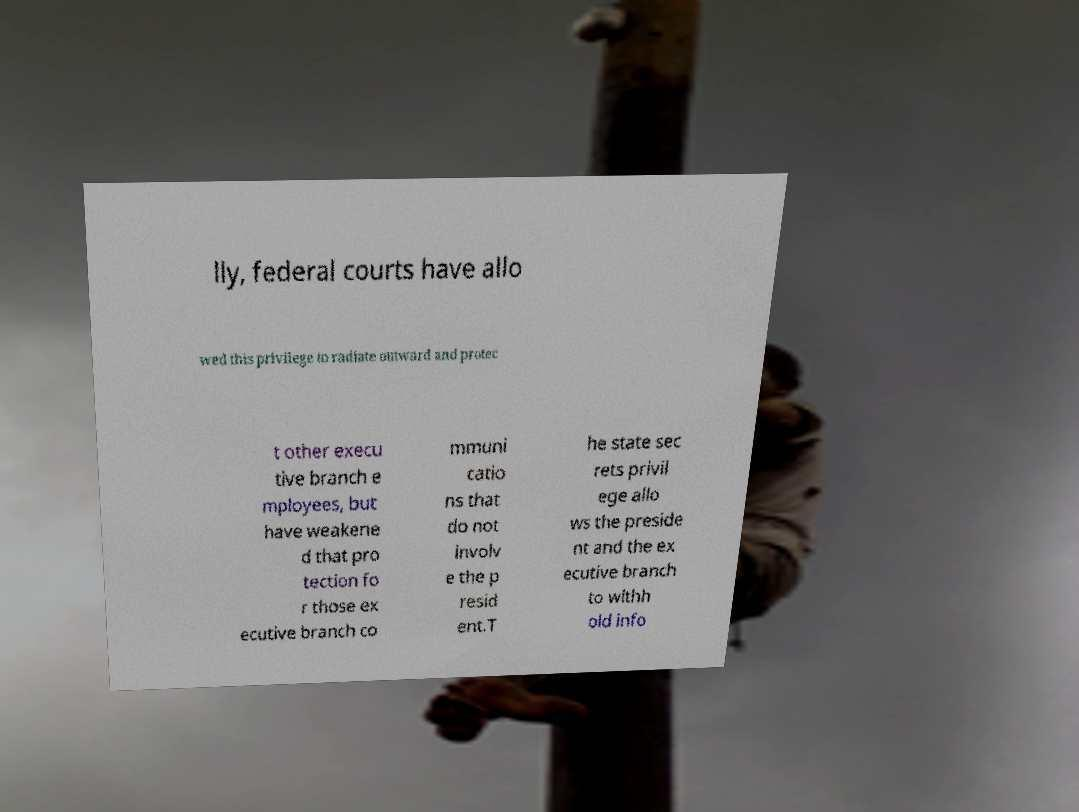Can you read and provide the text displayed in the image?This photo seems to have some interesting text. Can you extract and type it out for me? lly, federal courts have allo wed this privilege to radiate outward and protec t other execu tive branch e mployees, but have weakene d that pro tection fo r those ex ecutive branch co mmuni catio ns that do not involv e the p resid ent.T he state sec rets privil ege allo ws the preside nt and the ex ecutive branch to withh old info 